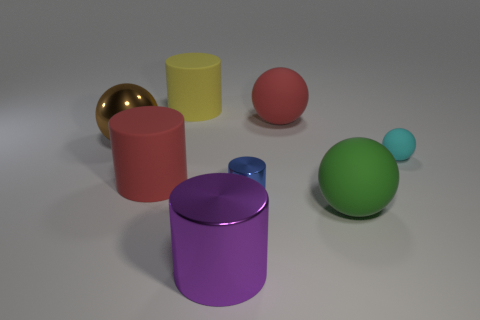There is a big object that is on the left side of the large red cylinder; how many red objects are in front of it?
Your answer should be compact. 1. Is there a big green rubber object that is left of the red rubber thing that is behind the large red rubber thing that is left of the yellow rubber cylinder?
Offer a very short reply. No. What material is the large yellow object that is the same shape as the tiny blue metal thing?
Offer a terse response. Rubber. Are there any other things that are made of the same material as the big green ball?
Ensure brevity in your answer.  Yes. Are the yellow thing and the big ball that is left of the big yellow object made of the same material?
Provide a short and direct response. No. There is a tiny object to the right of the red rubber object behind the shiny ball; what is its shape?
Ensure brevity in your answer.  Sphere. How many big objects are either metal objects or spheres?
Keep it short and to the point. 4. What number of other big rubber things are the same shape as the green object?
Offer a terse response. 1. There is a large yellow rubber object; is it the same shape as the big metallic object in front of the green sphere?
Your answer should be compact. Yes. What number of big shiny objects are in front of the brown shiny object?
Provide a short and direct response. 1. 